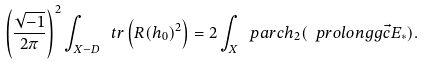<formula> <loc_0><loc_0><loc_500><loc_500>\left ( \frac { \sqrt { - 1 } } { 2 \pi } \right ) ^ { 2 } \int _ { X - D } \ t r \left ( R ( h _ { 0 } ) ^ { 2 } \right ) = 2 \int _ { X } \ p a r c h _ { 2 } ( \ p r o l o n g g { \vec { c } } { E } _ { \ast } ) .</formula> 